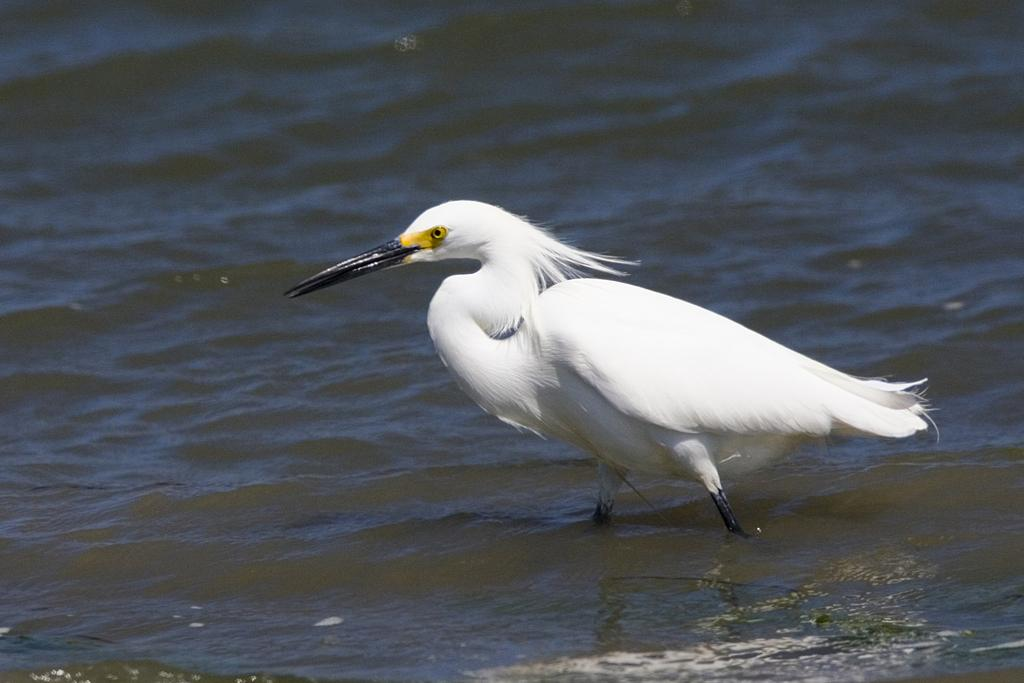What type of animal is in the image? There is a bird in the image. What color is the bird? The bird is white in color. Where is the bird located in the image? The bird is in the water. How many sisters does the bird have in the image? There is no mention of sisters or any other animals in the image, so it cannot be determined if the bird has any. 